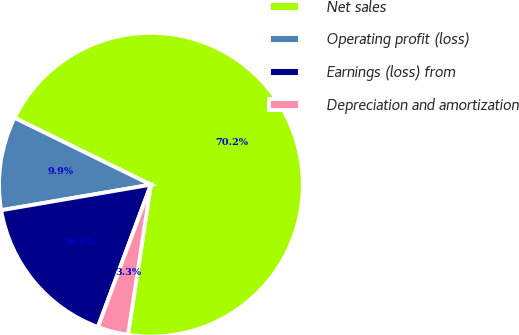<chart> <loc_0><loc_0><loc_500><loc_500><pie_chart><fcel>Net sales<fcel>Operating profit (loss)<fcel>Earnings (loss) from<fcel>Depreciation and amortization<nl><fcel>70.15%<fcel>9.95%<fcel>16.64%<fcel>3.26%<nl></chart> 